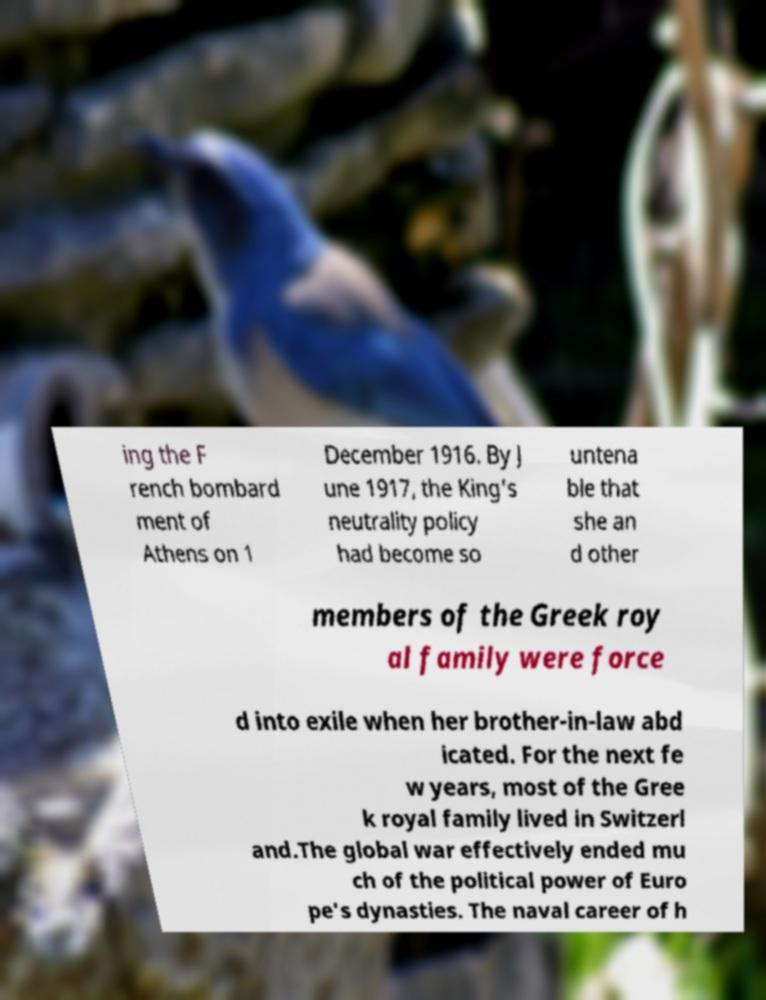Please read and relay the text visible in this image. What does it say? ing the F rench bombard ment of Athens on 1 December 1916. By J une 1917, the King's neutrality policy had become so untena ble that she an d other members of the Greek roy al family were force d into exile when her brother-in-law abd icated. For the next fe w years, most of the Gree k royal family lived in Switzerl and.The global war effectively ended mu ch of the political power of Euro pe's dynasties. The naval career of h 